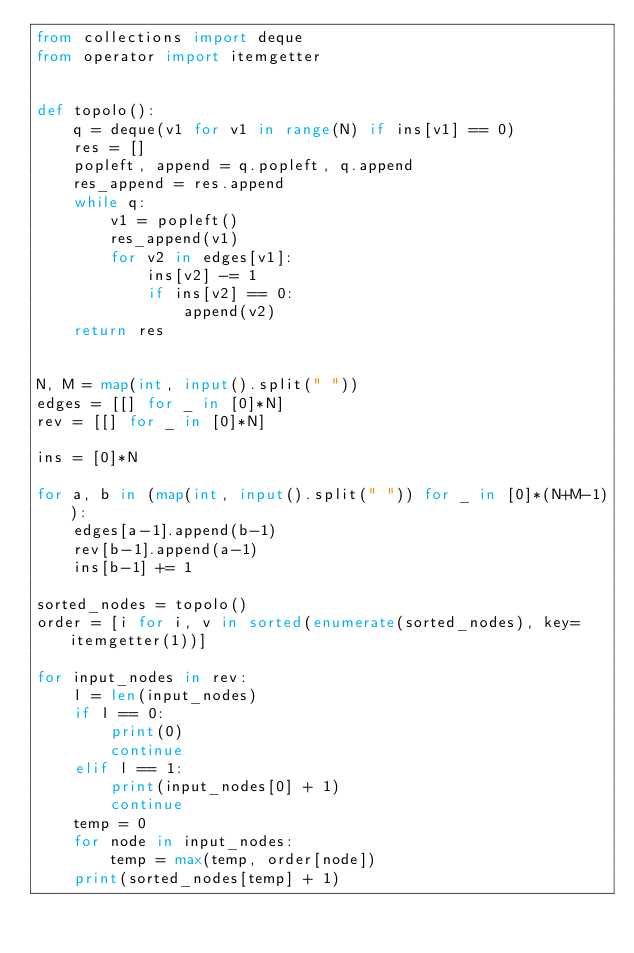<code> <loc_0><loc_0><loc_500><loc_500><_Python_>from collections import deque
from operator import itemgetter


def topolo():
    q = deque(v1 for v1 in range(N) if ins[v1] == 0)
    res = []
    popleft, append = q.popleft, q.append
    res_append = res.append
    while q:
        v1 = popleft()
        res_append(v1)
        for v2 in edges[v1]:
            ins[v2] -= 1
            if ins[v2] == 0:
                append(v2)
    return res


N, M = map(int, input().split(" "))
edges = [[] for _ in [0]*N]
rev = [[] for _ in [0]*N]

ins = [0]*N

for a, b in (map(int, input().split(" ")) for _ in [0]*(N+M-1)):
    edges[a-1].append(b-1)
    rev[b-1].append(a-1)
    ins[b-1] += 1

sorted_nodes = topolo()
order = [i for i, v in sorted(enumerate(sorted_nodes), key=itemgetter(1))]

for input_nodes in rev:
    l = len(input_nodes)
    if l == 0:
        print(0)
        continue
    elif l == 1:
        print(input_nodes[0] + 1)
        continue
    temp = 0
    for node in input_nodes:
        temp = max(temp, order[node])
    print(sorted_nodes[temp] + 1)
</code> 